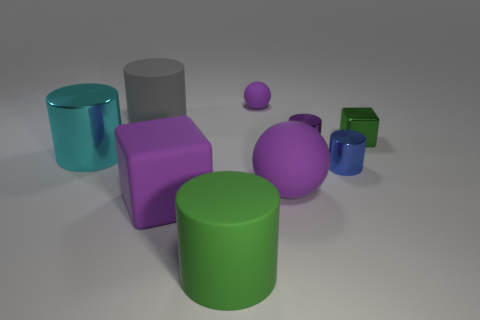Is there anything else that has the same size as the purple shiny thing? Comparing the objects in the image, the green cylinder appears to be of a similar height to the purple cube, although their shapes are different. 